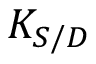Convert formula to latex. <formula><loc_0><loc_0><loc_500><loc_500>K _ { S / D }</formula> 